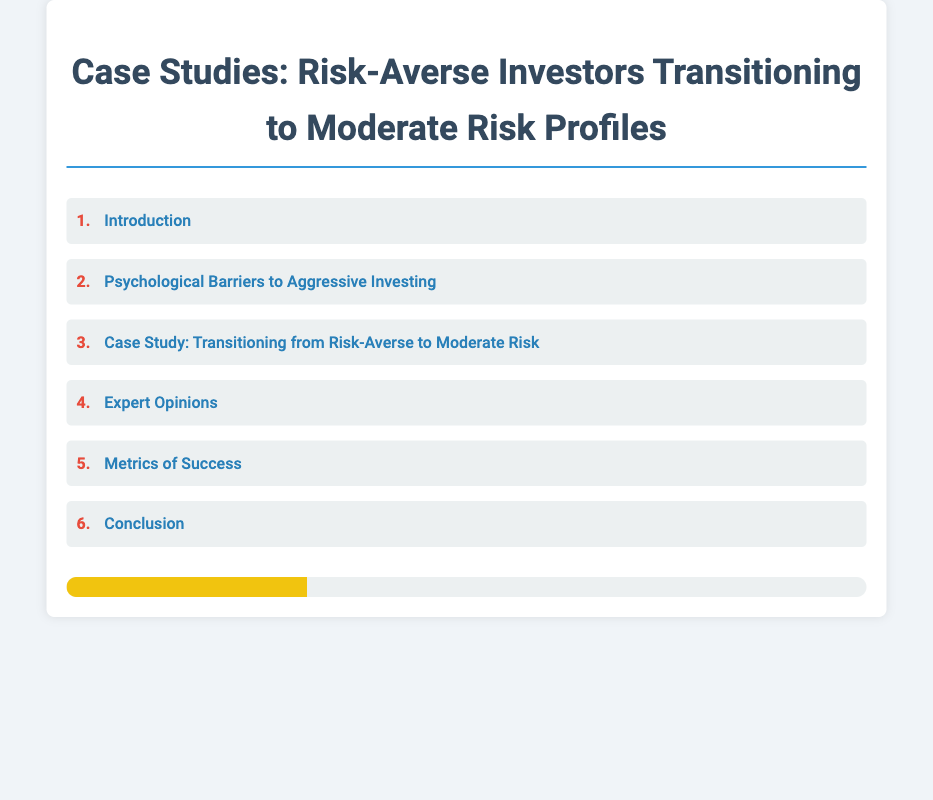What is the title of the document? The title of the document is stated in the HTML header as "Case Studies: Risk-Averse Investors Transitioning to Moderate Risk Profiles".
Answer: Case Studies: Risk-Averse Investors Transitioning to Moderate Risk Profiles What section discusses psychological barriers? Section 2 of the index is about psychological barriers to aggressive investing.
Answer: Psychological Barriers to Aggressive Investing How many case studies are mentioned? Based on the index, there is one dedicated case study listed under section 3.
Answer: 1 What is the last section of the document? The last section, as indicated in the index, is labeled 'Conclusion', which is section 6.
Answer: Conclusion What visual element indicates risk levels? The risk meter visually represents risk levels with an animated bar in the document.
Answer: Risk meter 